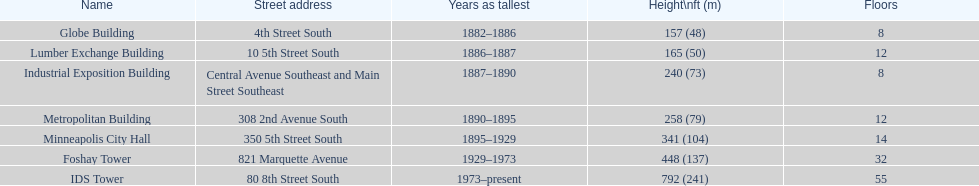Can you parse all the data within this table? {'header': ['Name', 'Street address', 'Years as tallest', 'Height\\nft (m)', 'Floors'], 'rows': [['Globe Building', '4th Street South', '1882–1886', '157 (48)', '8'], ['Lumber Exchange Building', '10 5th Street South', '1886–1887', '165 (50)', '12'], ['Industrial Exposition Building', 'Central Avenue Southeast and Main Street Southeast', '1887–1890', '240 (73)', '8'], ['Metropolitan Building', '308 2nd Avenue South', '1890–1895', '258 (79)', '12'], ['Minneapolis City Hall', '350 5th Street South', '1895–1929', '341 (104)', '14'], ['Foshay Tower', '821 Marquette Avenue', '1929–1973', '448 (137)', '32'], ['IDS Tower', '80 8th Street South', '1973–present', '792 (241)', '55']]} Which building has the same number of floors as the lumber exchange building? Metropolitan Building. 